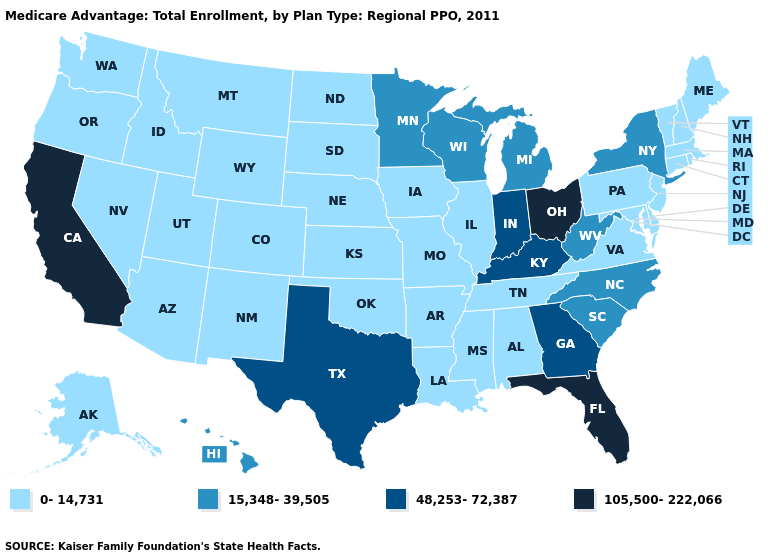Name the states that have a value in the range 15,348-39,505?
Write a very short answer. Hawaii, Michigan, Minnesota, North Carolina, New York, South Carolina, Wisconsin, West Virginia. What is the value of Hawaii?
Short answer required. 15,348-39,505. Which states have the highest value in the USA?
Concise answer only. California, Florida, Ohio. Which states have the highest value in the USA?
Concise answer only. California, Florida, Ohio. Which states have the highest value in the USA?
Give a very brief answer. California, Florida, Ohio. What is the value of Idaho?
Be succinct. 0-14,731. What is the value of Minnesota?
Short answer required. 15,348-39,505. Name the states that have a value in the range 48,253-72,387?
Concise answer only. Georgia, Indiana, Kentucky, Texas. Does the map have missing data?
Short answer required. No. Which states have the lowest value in the South?
Quick response, please. Alabama, Arkansas, Delaware, Louisiana, Maryland, Mississippi, Oklahoma, Tennessee, Virginia. Which states hav the highest value in the South?
Quick response, please. Florida. What is the value of Florida?
Short answer required. 105,500-222,066. Is the legend a continuous bar?
Write a very short answer. No. What is the highest value in the USA?
Quick response, please. 105,500-222,066. 